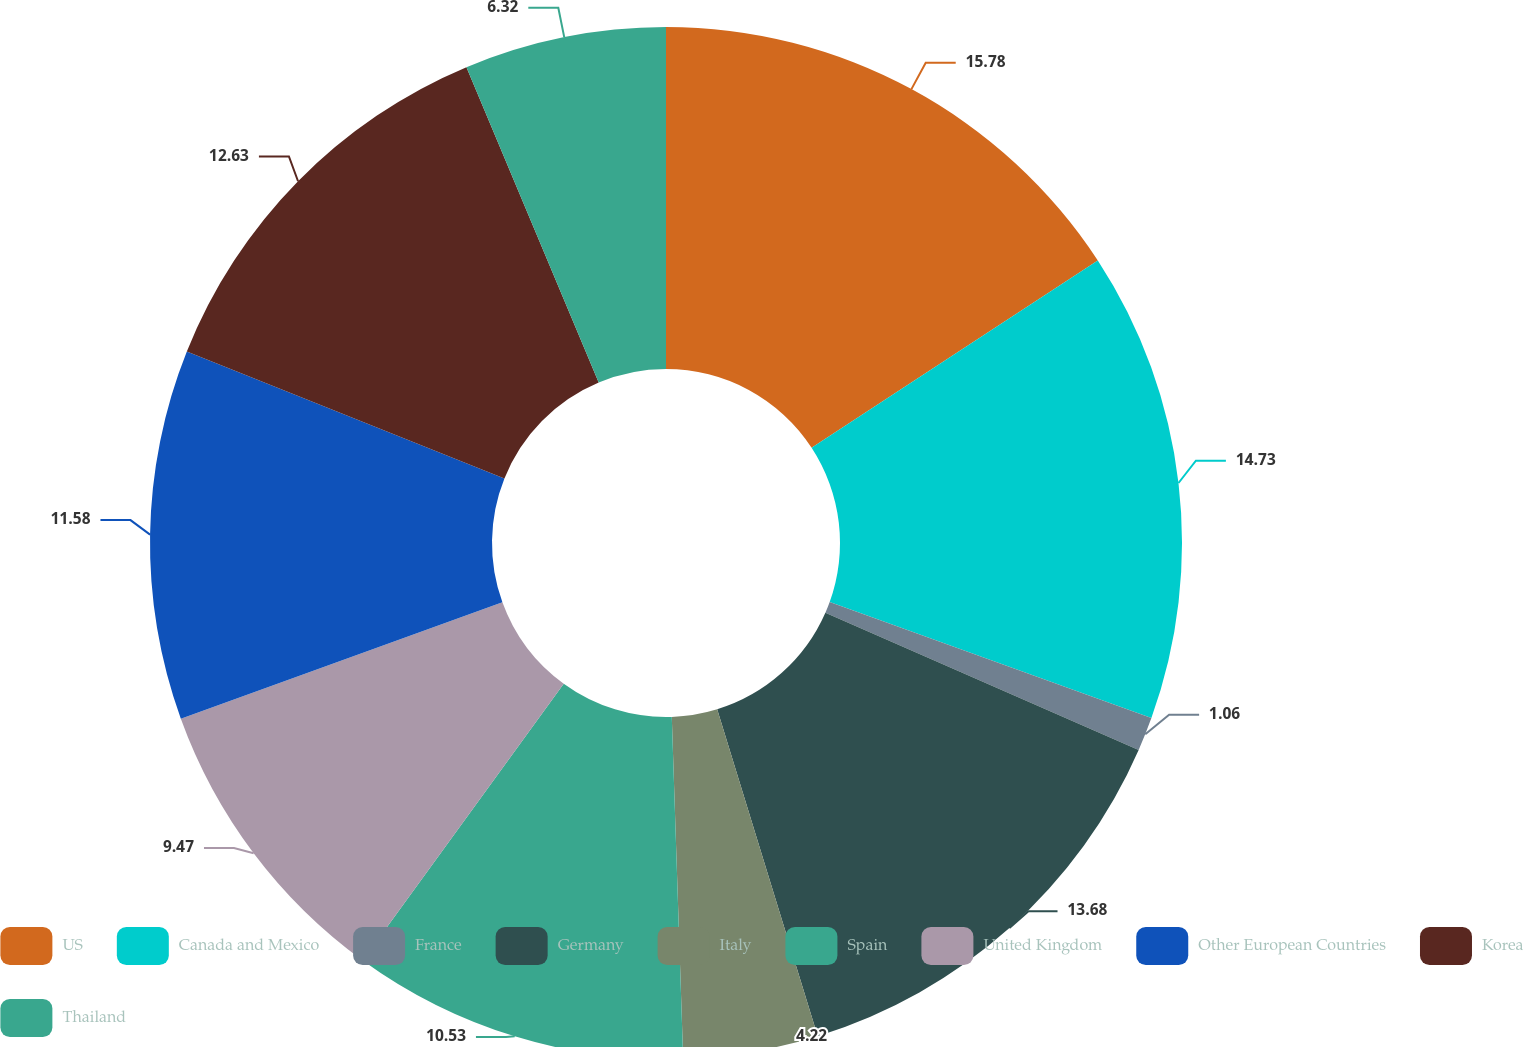Convert chart. <chart><loc_0><loc_0><loc_500><loc_500><pie_chart><fcel>US<fcel>Canada and Mexico<fcel>France<fcel>Germany<fcel>Italy<fcel>Spain<fcel>United Kingdom<fcel>Other European Countries<fcel>Korea<fcel>Thailand<nl><fcel>15.78%<fcel>14.73%<fcel>1.06%<fcel>13.68%<fcel>4.22%<fcel>10.53%<fcel>9.47%<fcel>11.58%<fcel>12.63%<fcel>6.32%<nl></chart> 